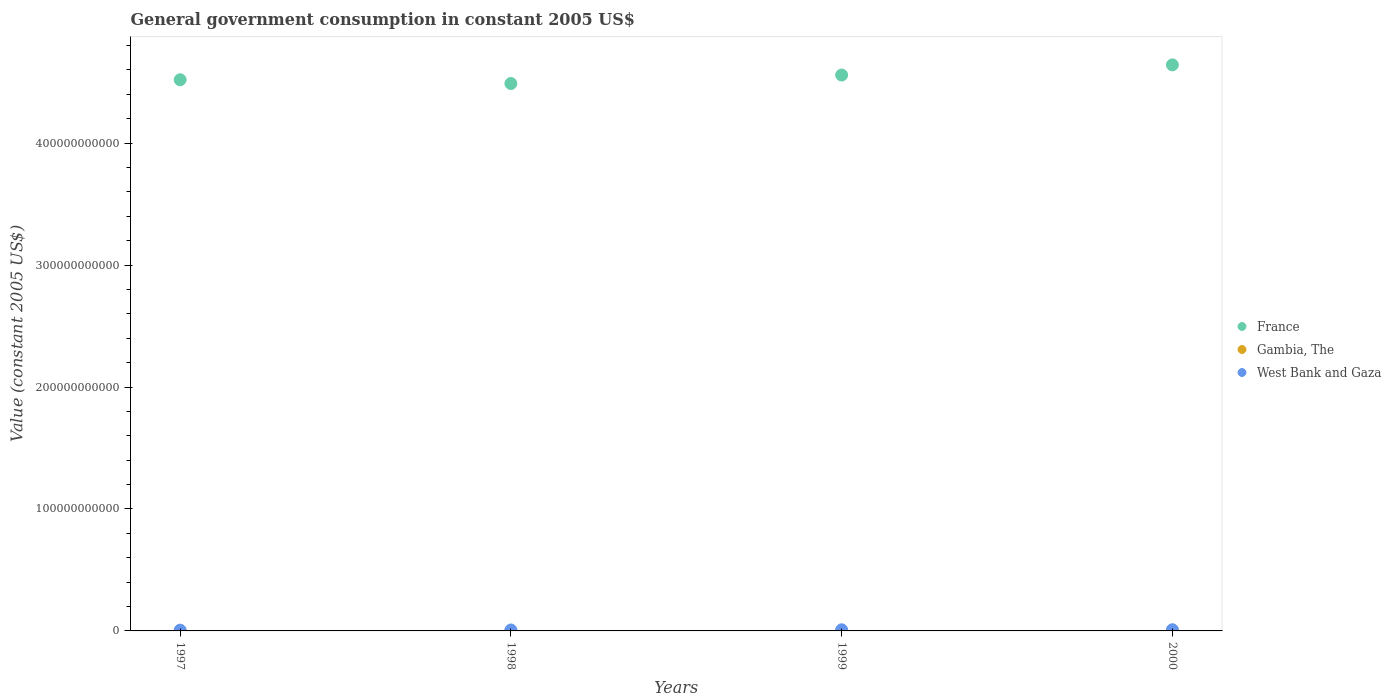Is the number of dotlines equal to the number of legend labels?
Your response must be concise. Yes. What is the government conusmption in West Bank and Gaza in 2000?
Ensure brevity in your answer.  9.70e+08. Across all years, what is the maximum government conusmption in West Bank and Gaza?
Your answer should be compact. 9.70e+08. Across all years, what is the minimum government conusmption in West Bank and Gaza?
Provide a short and direct response. 6.28e+08. In which year was the government conusmption in West Bank and Gaza maximum?
Your response must be concise. 2000. What is the total government conusmption in Gambia, The in the graph?
Make the answer very short. 1.26e+08. What is the difference between the government conusmption in Gambia, The in 1997 and that in 2000?
Your answer should be compact. -6.16e+06. What is the difference between the government conusmption in Gambia, The in 1997 and the government conusmption in West Bank and Gaza in 1999?
Provide a succinct answer. -8.91e+08. What is the average government conusmption in Gambia, The per year?
Your answer should be very brief. 3.15e+07. In the year 1997, what is the difference between the government conusmption in France and government conusmption in Gambia, The?
Provide a succinct answer. 4.52e+11. In how many years, is the government conusmption in West Bank and Gaza greater than 160000000000 US$?
Provide a short and direct response. 0. What is the ratio of the government conusmption in West Bank and Gaza in 1998 to that in 1999?
Your response must be concise. 0.84. Is the government conusmption in Gambia, The in 1999 less than that in 2000?
Your answer should be compact. Yes. What is the difference between the highest and the second highest government conusmption in France?
Your answer should be very brief. 8.34e+09. What is the difference between the highest and the lowest government conusmption in Gambia, The?
Provide a short and direct response. 7.36e+06. In how many years, is the government conusmption in Gambia, The greater than the average government conusmption in Gambia, The taken over all years?
Your answer should be very brief. 1. Is the sum of the government conusmption in France in 1997 and 2000 greater than the maximum government conusmption in Gambia, The across all years?
Offer a very short reply. Yes. Is it the case that in every year, the sum of the government conusmption in France and government conusmption in West Bank and Gaza  is greater than the government conusmption in Gambia, The?
Your response must be concise. Yes. Does the government conusmption in Gambia, The monotonically increase over the years?
Keep it short and to the point. No. Is the government conusmption in West Bank and Gaza strictly greater than the government conusmption in Gambia, The over the years?
Make the answer very short. Yes. What is the difference between two consecutive major ticks on the Y-axis?
Your answer should be compact. 1.00e+11. Where does the legend appear in the graph?
Keep it short and to the point. Center right. How many legend labels are there?
Ensure brevity in your answer.  3. What is the title of the graph?
Your answer should be very brief. General government consumption in constant 2005 US$. Does "Iceland" appear as one of the legend labels in the graph?
Keep it short and to the point. No. What is the label or title of the Y-axis?
Your answer should be very brief. Value (constant 2005 US$). What is the Value (constant 2005 US$) in France in 1997?
Give a very brief answer. 4.52e+11. What is the Value (constant 2005 US$) in Gambia, The in 1997?
Your answer should be compact. 2.99e+07. What is the Value (constant 2005 US$) of West Bank and Gaza in 1997?
Your response must be concise. 6.28e+08. What is the Value (constant 2005 US$) in France in 1998?
Keep it short and to the point. 4.49e+11. What is the Value (constant 2005 US$) of Gambia, The in 1998?
Your answer should be compact. 2.87e+07. What is the Value (constant 2005 US$) in West Bank and Gaza in 1998?
Your answer should be very brief. 7.71e+08. What is the Value (constant 2005 US$) of France in 1999?
Make the answer very short. 4.56e+11. What is the Value (constant 2005 US$) in Gambia, The in 1999?
Your answer should be very brief. 3.14e+07. What is the Value (constant 2005 US$) of West Bank and Gaza in 1999?
Give a very brief answer. 9.21e+08. What is the Value (constant 2005 US$) of France in 2000?
Make the answer very short. 4.64e+11. What is the Value (constant 2005 US$) in Gambia, The in 2000?
Your response must be concise. 3.60e+07. What is the Value (constant 2005 US$) in West Bank and Gaza in 2000?
Offer a terse response. 9.70e+08. Across all years, what is the maximum Value (constant 2005 US$) of France?
Your response must be concise. 4.64e+11. Across all years, what is the maximum Value (constant 2005 US$) of Gambia, The?
Provide a succinct answer. 3.60e+07. Across all years, what is the maximum Value (constant 2005 US$) of West Bank and Gaza?
Provide a succinct answer. 9.70e+08. Across all years, what is the minimum Value (constant 2005 US$) in France?
Make the answer very short. 4.49e+11. Across all years, what is the minimum Value (constant 2005 US$) of Gambia, The?
Keep it short and to the point. 2.87e+07. Across all years, what is the minimum Value (constant 2005 US$) of West Bank and Gaza?
Ensure brevity in your answer.  6.28e+08. What is the total Value (constant 2005 US$) in France in the graph?
Make the answer very short. 1.82e+12. What is the total Value (constant 2005 US$) in Gambia, The in the graph?
Give a very brief answer. 1.26e+08. What is the total Value (constant 2005 US$) of West Bank and Gaza in the graph?
Keep it short and to the point. 3.29e+09. What is the difference between the Value (constant 2005 US$) of France in 1997 and that in 1998?
Offer a terse response. 3.09e+09. What is the difference between the Value (constant 2005 US$) of Gambia, The in 1997 and that in 1998?
Provide a succinct answer. 1.20e+06. What is the difference between the Value (constant 2005 US$) in West Bank and Gaza in 1997 and that in 1998?
Your answer should be compact. -1.43e+08. What is the difference between the Value (constant 2005 US$) in France in 1997 and that in 1999?
Your response must be concise. -3.86e+09. What is the difference between the Value (constant 2005 US$) of Gambia, The in 1997 and that in 1999?
Provide a short and direct response. -1.56e+06. What is the difference between the Value (constant 2005 US$) in West Bank and Gaza in 1997 and that in 1999?
Keep it short and to the point. -2.94e+08. What is the difference between the Value (constant 2005 US$) in France in 1997 and that in 2000?
Your answer should be compact. -1.22e+1. What is the difference between the Value (constant 2005 US$) of Gambia, The in 1997 and that in 2000?
Provide a short and direct response. -6.16e+06. What is the difference between the Value (constant 2005 US$) of West Bank and Gaza in 1997 and that in 2000?
Offer a terse response. -3.43e+08. What is the difference between the Value (constant 2005 US$) of France in 1998 and that in 1999?
Make the answer very short. -6.94e+09. What is the difference between the Value (constant 2005 US$) of Gambia, The in 1998 and that in 1999?
Ensure brevity in your answer.  -2.76e+06. What is the difference between the Value (constant 2005 US$) of West Bank and Gaza in 1998 and that in 1999?
Your answer should be very brief. -1.50e+08. What is the difference between the Value (constant 2005 US$) of France in 1998 and that in 2000?
Provide a short and direct response. -1.53e+1. What is the difference between the Value (constant 2005 US$) in Gambia, The in 1998 and that in 2000?
Ensure brevity in your answer.  -7.36e+06. What is the difference between the Value (constant 2005 US$) in West Bank and Gaza in 1998 and that in 2000?
Provide a succinct answer. -2.00e+08. What is the difference between the Value (constant 2005 US$) in France in 1999 and that in 2000?
Keep it short and to the point. -8.34e+09. What is the difference between the Value (constant 2005 US$) in Gambia, The in 1999 and that in 2000?
Ensure brevity in your answer.  -4.60e+06. What is the difference between the Value (constant 2005 US$) in West Bank and Gaza in 1999 and that in 2000?
Make the answer very short. -4.91e+07. What is the difference between the Value (constant 2005 US$) of France in 1997 and the Value (constant 2005 US$) of Gambia, The in 1998?
Your answer should be very brief. 4.52e+11. What is the difference between the Value (constant 2005 US$) in France in 1997 and the Value (constant 2005 US$) in West Bank and Gaza in 1998?
Provide a succinct answer. 4.51e+11. What is the difference between the Value (constant 2005 US$) in Gambia, The in 1997 and the Value (constant 2005 US$) in West Bank and Gaza in 1998?
Provide a succinct answer. -7.41e+08. What is the difference between the Value (constant 2005 US$) of France in 1997 and the Value (constant 2005 US$) of Gambia, The in 1999?
Offer a terse response. 4.52e+11. What is the difference between the Value (constant 2005 US$) of France in 1997 and the Value (constant 2005 US$) of West Bank and Gaza in 1999?
Ensure brevity in your answer.  4.51e+11. What is the difference between the Value (constant 2005 US$) of Gambia, The in 1997 and the Value (constant 2005 US$) of West Bank and Gaza in 1999?
Provide a succinct answer. -8.91e+08. What is the difference between the Value (constant 2005 US$) in France in 1997 and the Value (constant 2005 US$) in Gambia, The in 2000?
Keep it short and to the point. 4.52e+11. What is the difference between the Value (constant 2005 US$) of France in 1997 and the Value (constant 2005 US$) of West Bank and Gaza in 2000?
Give a very brief answer. 4.51e+11. What is the difference between the Value (constant 2005 US$) in Gambia, The in 1997 and the Value (constant 2005 US$) in West Bank and Gaza in 2000?
Provide a succinct answer. -9.40e+08. What is the difference between the Value (constant 2005 US$) of France in 1998 and the Value (constant 2005 US$) of Gambia, The in 1999?
Provide a succinct answer. 4.49e+11. What is the difference between the Value (constant 2005 US$) in France in 1998 and the Value (constant 2005 US$) in West Bank and Gaza in 1999?
Make the answer very short. 4.48e+11. What is the difference between the Value (constant 2005 US$) of Gambia, The in 1998 and the Value (constant 2005 US$) of West Bank and Gaza in 1999?
Give a very brief answer. -8.93e+08. What is the difference between the Value (constant 2005 US$) of France in 1998 and the Value (constant 2005 US$) of Gambia, The in 2000?
Offer a very short reply. 4.49e+11. What is the difference between the Value (constant 2005 US$) in France in 1998 and the Value (constant 2005 US$) in West Bank and Gaza in 2000?
Offer a very short reply. 4.48e+11. What is the difference between the Value (constant 2005 US$) in Gambia, The in 1998 and the Value (constant 2005 US$) in West Bank and Gaza in 2000?
Your answer should be very brief. -9.42e+08. What is the difference between the Value (constant 2005 US$) in France in 1999 and the Value (constant 2005 US$) in Gambia, The in 2000?
Offer a terse response. 4.56e+11. What is the difference between the Value (constant 2005 US$) of France in 1999 and the Value (constant 2005 US$) of West Bank and Gaza in 2000?
Your answer should be compact. 4.55e+11. What is the difference between the Value (constant 2005 US$) of Gambia, The in 1999 and the Value (constant 2005 US$) of West Bank and Gaza in 2000?
Your response must be concise. -9.39e+08. What is the average Value (constant 2005 US$) of France per year?
Ensure brevity in your answer.  4.55e+11. What is the average Value (constant 2005 US$) in Gambia, The per year?
Give a very brief answer. 3.15e+07. What is the average Value (constant 2005 US$) in West Bank and Gaza per year?
Your answer should be compact. 8.22e+08. In the year 1997, what is the difference between the Value (constant 2005 US$) of France and Value (constant 2005 US$) of Gambia, The?
Provide a succinct answer. 4.52e+11. In the year 1997, what is the difference between the Value (constant 2005 US$) of France and Value (constant 2005 US$) of West Bank and Gaza?
Keep it short and to the point. 4.51e+11. In the year 1997, what is the difference between the Value (constant 2005 US$) of Gambia, The and Value (constant 2005 US$) of West Bank and Gaza?
Your answer should be very brief. -5.98e+08. In the year 1998, what is the difference between the Value (constant 2005 US$) in France and Value (constant 2005 US$) in Gambia, The?
Keep it short and to the point. 4.49e+11. In the year 1998, what is the difference between the Value (constant 2005 US$) of France and Value (constant 2005 US$) of West Bank and Gaza?
Offer a very short reply. 4.48e+11. In the year 1998, what is the difference between the Value (constant 2005 US$) of Gambia, The and Value (constant 2005 US$) of West Bank and Gaza?
Your answer should be compact. -7.42e+08. In the year 1999, what is the difference between the Value (constant 2005 US$) of France and Value (constant 2005 US$) of Gambia, The?
Ensure brevity in your answer.  4.56e+11. In the year 1999, what is the difference between the Value (constant 2005 US$) in France and Value (constant 2005 US$) in West Bank and Gaza?
Your answer should be compact. 4.55e+11. In the year 1999, what is the difference between the Value (constant 2005 US$) in Gambia, The and Value (constant 2005 US$) in West Bank and Gaza?
Your answer should be very brief. -8.90e+08. In the year 2000, what is the difference between the Value (constant 2005 US$) in France and Value (constant 2005 US$) in Gambia, The?
Offer a very short reply. 4.64e+11. In the year 2000, what is the difference between the Value (constant 2005 US$) in France and Value (constant 2005 US$) in West Bank and Gaza?
Make the answer very short. 4.63e+11. In the year 2000, what is the difference between the Value (constant 2005 US$) of Gambia, The and Value (constant 2005 US$) of West Bank and Gaza?
Give a very brief answer. -9.34e+08. What is the ratio of the Value (constant 2005 US$) of France in 1997 to that in 1998?
Offer a very short reply. 1.01. What is the ratio of the Value (constant 2005 US$) in Gambia, The in 1997 to that in 1998?
Provide a succinct answer. 1.04. What is the ratio of the Value (constant 2005 US$) of West Bank and Gaza in 1997 to that in 1998?
Your answer should be compact. 0.81. What is the ratio of the Value (constant 2005 US$) in Gambia, The in 1997 to that in 1999?
Make the answer very short. 0.95. What is the ratio of the Value (constant 2005 US$) of West Bank and Gaza in 1997 to that in 1999?
Provide a succinct answer. 0.68. What is the ratio of the Value (constant 2005 US$) in France in 1997 to that in 2000?
Your response must be concise. 0.97. What is the ratio of the Value (constant 2005 US$) of Gambia, The in 1997 to that in 2000?
Offer a terse response. 0.83. What is the ratio of the Value (constant 2005 US$) in West Bank and Gaza in 1997 to that in 2000?
Offer a very short reply. 0.65. What is the ratio of the Value (constant 2005 US$) of France in 1998 to that in 1999?
Provide a short and direct response. 0.98. What is the ratio of the Value (constant 2005 US$) in Gambia, The in 1998 to that in 1999?
Give a very brief answer. 0.91. What is the ratio of the Value (constant 2005 US$) of West Bank and Gaza in 1998 to that in 1999?
Provide a succinct answer. 0.84. What is the ratio of the Value (constant 2005 US$) of France in 1998 to that in 2000?
Your answer should be very brief. 0.97. What is the ratio of the Value (constant 2005 US$) of Gambia, The in 1998 to that in 2000?
Make the answer very short. 0.8. What is the ratio of the Value (constant 2005 US$) in West Bank and Gaza in 1998 to that in 2000?
Provide a succinct answer. 0.79. What is the ratio of the Value (constant 2005 US$) of Gambia, The in 1999 to that in 2000?
Your response must be concise. 0.87. What is the ratio of the Value (constant 2005 US$) in West Bank and Gaza in 1999 to that in 2000?
Give a very brief answer. 0.95. What is the difference between the highest and the second highest Value (constant 2005 US$) of France?
Ensure brevity in your answer.  8.34e+09. What is the difference between the highest and the second highest Value (constant 2005 US$) of Gambia, The?
Make the answer very short. 4.60e+06. What is the difference between the highest and the second highest Value (constant 2005 US$) in West Bank and Gaza?
Ensure brevity in your answer.  4.91e+07. What is the difference between the highest and the lowest Value (constant 2005 US$) of France?
Your response must be concise. 1.53e+1. What is the difference between the highest and the lowest Value (constant 2005 US$) of Gambia, The?
Your answer should be compact. 7.36e+06. What is the difference between the highest and the lowest Value (constant 2005 US$) in West Bank and Gaza?
Make the answer very short. 3.43e+08. 